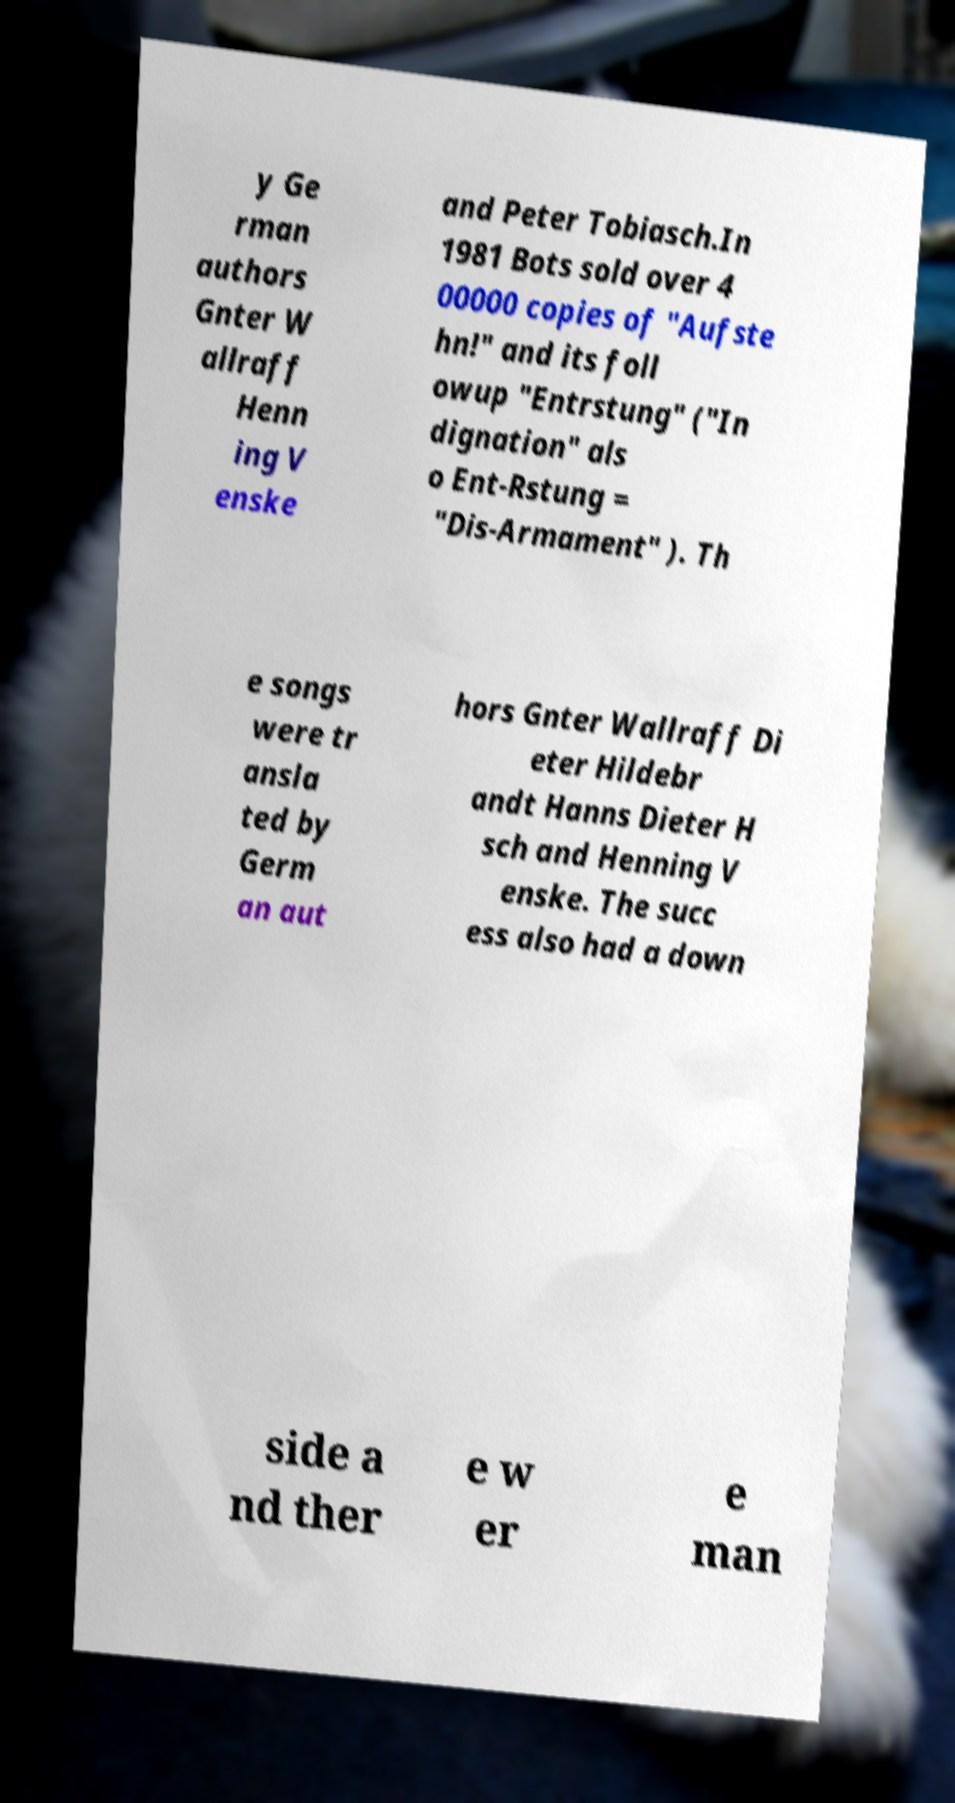There's text embedded in this image that I need extracted. Can you transcribe it verbatim? y Ge rman authors Gnter W allraff Henn ing V enske and Peter Tobiasch.In 1981 Bots sold over 4 00000 copies of "Aufste hn!" and its foll owup "Entrstung" ("In dignation" als o Ent-Rstung = "Dis-Armament" ). Th e songs were tr ansla ted by Germ an aut hors Gnter Wallraff Di eter Hildebr andt Hanns Dieter H sch and Henning V enske. The succ ess also had a down side a nd ther e w er e man 